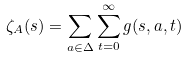Convert formula to latex. <formula><loc_0><loc_0><loc_500><loc_500>\zeta _ { A } ( s ) = \sum _ { a \in \Delta } \sum ^ { \infty } _ { t = 0 } g ( s , a , t )</formula> 